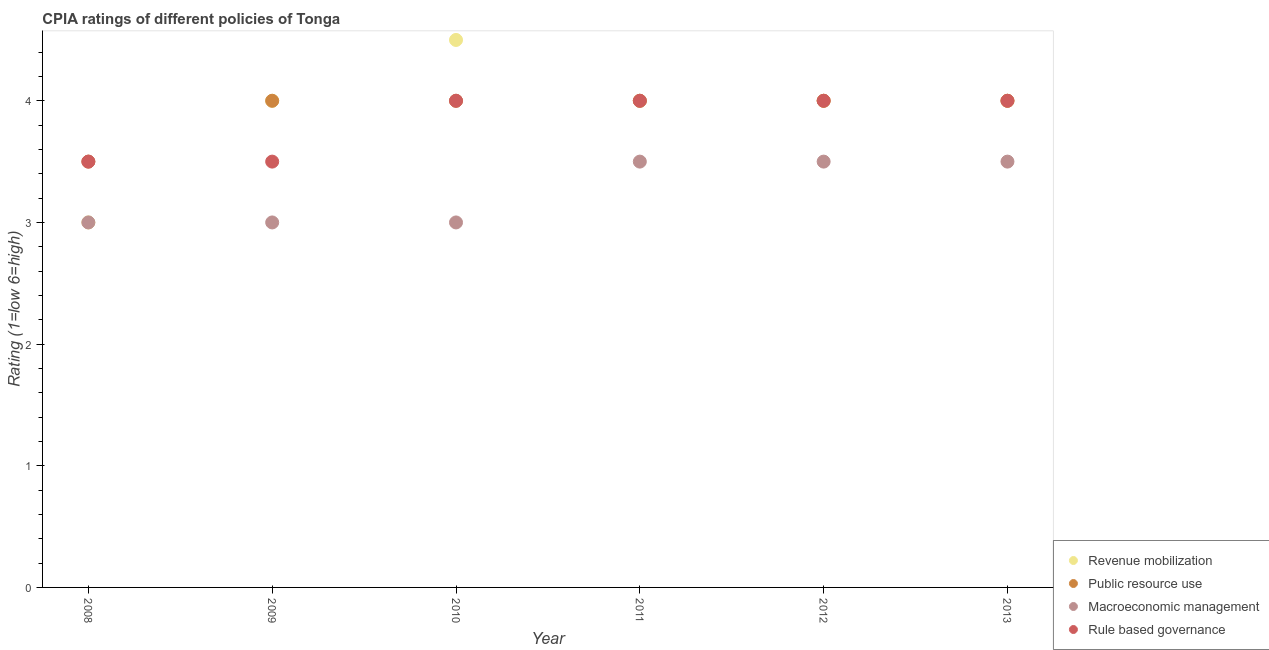How many different coloured dotlines are there?
Your answer should be very brief. 4. Is the number of dotlines equal to the number of legend labels?
Offer a terse response. Yes. Across all years, what is the maximum cpia rating of macroeconomic management?
Keep it short and to the point. 3.5. Across all years, what is the minimum cpia rating of macroeconomic management?
Keep it short and to the point. 3. In which year was the cpia rating of rule based governance maximum?
Provide a short and direct response. 2010. In which year was the cpia rating of public resource use minimum?
Your answer should be very brief. 2008. What is the total cpia rating of revenue mobilization in the graph?
Make the answer very short. 23.5. What is the difference between the cpia rating of public resource use in 2010 and the cpia rating of revenue mobilization in 2009?
Give a very brief answer. 0. What is the ratio of the cpia rating of macroeconomic management in 2008 to that in 2013?
Provide a short and direct response. 0.86. Is the cpia rating of public resource use in 2009 less than that in 2012?
Make the answer very short. No. Is the difference between the cpia rating of macroeconomic management in 2008 and 2010 greater than the difference between the cpia rating of rule based governance in 2008 and 2010?
Your answer should be compact. Yes. What is the difference between the highest and the lowest cpia rating of revenue mobilization?
Your response must be concise. 1.5. In how many years, is the cpia rating of macroeconomic management greater than the average cpia rating of macroeconomic management taken over all years?
Offer a very short reply. 3. Is the sum of the cpia rating of public resource use in 2009 and 2010 greater than the maximum cpia rating of macroeconomic management across all years?
Your answer should be compact. Yes. Is it the case that in every year, the sum of the cpia rating of revenue mobilization and cpia rating of public resource use is greater than the sum of cpia rating of rule based governance and cpia rating of macroeconomic management?
Provide a short and direct response. No. How many years are there in the graph?
Ensure brevity in your answer.  6. What is the difference between two consecutive major ticks on the Y-axis?
Make the answer very short. 1. Does the graph contain any zero values?
Your response must be concise. No. Does the graph contain grids?
Offer a very short reply. No. Where does the legend appear in the graph?
Make the answer very short. Bottom right. What is the title of the graph?
Your answer should be very brief. CPIA ratings of different policies of Tonga. Does "UNAIDS" appear as one of the legend labels in the graph?
Offer a terse response. No. What is the label or title of the X-axis?
Ensure brevity in your answer.  Year. What is the label or title of the Y-axis?
Your answer should be very brief. Rating (1=low 6=high). What is the Rating (1=low 6=high) of Public resource use in 2008?
Keep it short and to the point. 3.5. What is the Rating (1=low 6=high) in Revenue mobilization in 2009?
Make the answer very short. 4. What is the Rating (1=low 6=high) of Macroeconomic management in 2009?
Keep it short and to the point. 3. What is the Rating (1=low 6=high) in Revenue mobilization in 2010?
Your response must be concise. 4.5. What is the Rating (1=low 6=high) in Public resource use in 2010?
Offer a terse response. 4. What is the Rating (1=low 6=high) in Rule based governance in 2011?
Your answer should be compact. 4. What is the Rating (1=low 6=high) in Public resource use in 2012?
Ensure brevity in your answer.  4. What is the Rating (1=low 6=high) in Macroeconomic management in 2013?
Your response must be concise. 3.5. What is the Rating (1=low 6=high) of Rule based governance in 2013?
Offer a terse response. 4. Across all years, what is the maximum Rating (1=low 6=high) in Macroeconomic management?
Ensure brevity in your answer.  3.5. Across all years, what is the minimum Rating (1=low 6=high) in Public resource use?
Your answer should be very brief. 3.5. What is the total Rating (1=low 6=high) of Revenue mobilization in the graph?
Offer a terse response. 23.5. What is the total Rating (1=low 6=high) of Public resource use in the graph?
Your answer should be very brief. 23.5. What is the total Rating (1=low 6=high) in Rule based governance in the graph?
Provide a short and direct response. 23. What is the difference between the Rating (1=low 6=high) of Public resource use in 2008 and that in 2009?
Ensure brevity in your answer.  -0.5. What is the difference between the Rating (1=low 6=high) of Revenue mobilization in 2008 and that in 2010?
Offer a terse response. -1.5. What is the difference between the Rating (1=low 6=high) of Macroeconomic management in 2008 and that in 2010?
Provide a succinct answer. 0. What is the difference between the Rating (1=low 6=high) in Rule based governance in 2008 and that in 2010?
Your answer should be compact. -0.5. What is the difference between the Rating (1=low 6=high) in Revenue mobilization in 2008 and that in 2011?
Offer a terse response. -1. What is the difference between the Rating (1=low 6=high) of Public resource use in 2008 and that in 2011?
Provide a succinct answer. -0.5. What is the difference between the Rating (1=low 6=high) of Rule based governance in 2008 and that in 2011?
Provide a succinct answer. -0.5. What is the difference between the Rating (1=low 6=high) of Revenue mobilization in 2008 and that in 2012?
Make the answer very short. -1. What is the difference between the Rating (1=low 6=high) in Public resource use in 2008 and that in 2012?
Your answer should be compact. -0.5. What is the difference between the Rating (1=low 6=high) in Macroeconomic management in 2008 and that in 2012?
Your answer should be compact. -0.5. What is the difference between the Rating (1=low 6=high) of Revenue mobilization in 2008 and that in 2013?
Keep it short and to the point. -1. What is the difference between the Rating (1=low 6=high) of Public resource use in 2008 and that in 2013?
Provide a short and direct response. -0.5. What is the difference between the Rating (1=low 6=high) of Macroeconomic management in 2008 and that in 2013?
Make the answer very short. -0.5. What is the difference between the Rating (1=low 6=high) of Rule based governance in 2008 and that in 2013?
Give a very brief answer. -0.5. What is the difference between the Rating (1=low 6=high) of Revenue mobilization in 2009 and that in 2010?
Offer a terse response. -0.5. What is the difference between the Rating (1=low 6=high) in Macroeconomic management in 2009 and that in 2010?
Provide a short and direct response. 0. What is the difference between the Rating (1=low 6=high) in Revenue mobilization in 2009 and that in 2011?
Your response must be concise. 0. What is the difference between the Rating (1=low 6=high) in Public resource use in 2009 and that in 2011?
Provide a succinct answer. 0. What is the difference between the Rating (1=low 6=high) in Macroeconomic management in 2009 and that in 2011?
Your response must be concise. -0.5. What is the difference between the Rating (1=low 6=high) in Public resource use in 2009 and that in 2012?
Provide a short and direct response. 0. What is the difference between the Rating (1=low 6=high) of Macroeconomic management in 2009 and that in 2012?
Make the answer very short. -0.5. What is the difference between the Rating (1=low 6=high) in Revenue mobilization in 2009 and that in 2013?
Make the answer very short. 0. What is the difference between the Rating (1=low 6=high) in Rule based governance in 2009 and that in 2013?
Offer a very short reply. -0.5. What is the difference between the Rating (1=low 6=high) in Public resource use in 2010 and that in 2011?
Give a very brief answer. 0. What is the difference between the Rating (1=low 6=high) of Rule based governance in 2010 and that in 2011?
Your answer should be very brief. 0. What is the difference between the Rating (1=low 6=high) in Revenue mobilization in 2010 and that in 2012?
Keep it short and to the point. 0.5. What is the difference between the Rating (1=low 6=high) in Public resource use in 2010 and that in 2012?
Give a very brief answer. 0. What is the difference between the Rating (1=low 6=high) of Revenue mobilization in 2010 and that in 2013?
Provide a succinct answer. 0.5. What is the difference between the Rating (1=low 6=high) in Rule based governance in 2011 and that in 2012?
Provide a succinct answer. 0. What is the difference between the Rating (1=low 6=high) of Rule based governance in 2011 and that in 2013?
Your answer should be compact. 0. What is the difference between the Rating (1=low 6=high) in Macroeconomic management in 2012 and that in 2013?
Keep it short and to the point. 0. What is the difference between the Rating (1=low 6=high) of Rule based governance in 2012 and that in 2013?
Provide a succinct answer. 0. What is the difference between the Rating (1=low 6=high) in Revenue mobilization in 2008 and the Rating (1=low 6=high) in Macroeconomic management in 2009?
Your answer should be compact. 0. What is the difference between the Rating (1=low 6=high) in Macroeconomic management in 2008 and the Rating (1=low 6=high) in Rule based governance in 2009?
Your answer should be very brief. -0.5. What is the difference between the Rating (1=low 6=high) of Revenue mobilization in 2008 and the Rating (1=low 6=high) of Macroeconomic management in 2010?
Give a very brief answer. 0. What is the difference between the Rating (1=low 6=high) in Public resource use in 2008 and the Rating (1=low 6=high) in Macroeconomic management in 2010?
Provide a succinct answer. 0.5. What is the difference between the Rating (1=low 6=high) in Public resource use in 2008 and the Rating (1=low 6=high) in Rule based governance in 2010?
Offer a very short reply. -0.5. What is the difference between the Rating (1=low 6=high) in Revenue mobilization in 2008 and the Rating (1=low 6=high) in Public resource use in 2011?
Ensure brevity in your answer.  -1. What is the difference between the Rating (1=low 6=high) in Revenue mobilization in 2008 and the Rating (1=low 6=high) in Macroeconomic management in 2011?
Your answer should be compact. -0.5. What is the difference between the Rating (1=low 6=high) of Public resource use in 2008 and the Rating (1=low 6=high) of Macroeconomic management in 2011?
Your answer should be very brief. 0. What is the difference between the Rating (1=low 6=high) of Public resource use in 2008 and the Rating (1=low 6=high) of Rule based governance in 2011?
Your answer should be very brief. -0.5. What is the difference between the Rating (1=low 6=high) in Revenue mobilization in 2008 and the Rating (1=low 6=high) in Macroeconomic management in 2012?
Keep it short and to the point. -0.5. What is the difference between the Rating (1=low 6=high) of Public resource use in 2008 and the Rating (1=low 6=high) of Rule based governance in 2012?
Your answer should be very brief. -0.5. What is the difference between the Rating (1=low 6=high) of Revenue mobilization in 2008 and the Rating (1=low 6=high) of Rule based governance in 2013?
Offer a terse response. -1. What is the difference between the Rating (1=low 6=high) in Public resource use in 2008 and the Rating (1=low 6=high) in Macroeconomic management in 2013?
Your answer should be very brief. 0. What is the difference between the Rating (1=low 6=high) of Macroeconomic management in 2008 and the Rating (1=low 6=high) of Rule based governance in 2013?
Ensure brevity in your answer.  -1. What is the difference between the Rating (1=low 6=high) of Revenue mobilization in 2009 and the Rating (1=low 6=high) of Public resource use in 2010?
Provide a succinct answer. 0. What is the difference between the Rating (1=low 6=high) of Revenue mobilization in 2009 and the Rating (1=low 6=high) of Macroeconomic management in 2010?
Offer a terse response. 1. What is the difference between the Rating (1=low 6=high) of Public resource use in 2009 and the Rating (1=low 6=high) of Rule based governance in 2010?
Ensure brevity in your answer.  0. What is the difference between the Rating (1=low 6=high) in Macroeconomic management in 2009 and the Rating (1=low 6=high) in Rule based governance in 2010?
Your answer should be very brief. -1. What is the difference between the Rating (1=low 6=high) in Public resource use in 2009 and the Rating (1=low 6=high) in Macroeconomic management in 2011?
Offer a terse response. 0.5. What is the difference between the Rating (1=low 6=high) of Revenue mobilization in 2009 and the Rating (1=low 6=high) of Public resource use in 2012?
Your answer should be compact. 0. What is the difference between the Rating (1=low 6=high) of Revenue mobilization in 2009 and the Rating (1=low 6=high) of Macroeconomic management in 2012?
Your response must be concise. 0.5. What is the difference between the Rating (1=low 6=high) in Revenue mobilization in 2009 and the Rating (1=low 6=high) in Rule based governance in 2012?
Ensure brevity in your answer.  0. What is the difference between the Rating (1=low 6=high) in Macroeconomic management in 2009 and the Rating (1=low 6=high) in Rule based governance in 2012?
Ensure brevity in your answer.  -1. What is the difference between the Rating (1=low 6=high) in Revenue mobilization in 2009 and the Rating (1=low 6=high) in Public resource use in 2013?
Provide a short and direct response. 0. What is the difference between the Rating (1=low 6=high) in Revenue mobilization in 2009 and the Rating (1=low 6=high) in Rule based governance in 2013?
Provide a short and direct response. 0. What is the difference between the Rating (1=low 6=high) of Public resource use in 2009 and the Rating (1=low 6=high) of Rule based governance in 2013?
Provide a short and direct response. 0. What is the difference between the Rating (1=low 6=high) in Macroeconomic management in 2009 and the Rating (1=low 6=high) in Rule based governance in 2013?
Provide a succinct answer. -1. What is the difference between the Rating (1=low 6=high) of Public resource use in 2010 and the Rating (1=low 6=high) of Macroeconomic management in 2011?
Make the answer very short. 0.5. What is the difference between the Rating (1=low 6=high) in Macroeconomic management in 2010 and the Rating (1=low 6=high) in Rule based governance in 2011?
Your answer should be compact. -1. What is the difference between the Rating (1=low 6=high) of Revenue mobilization in 2010 and the Rating (1=low 6=high) of Public resource use in 2012?
Your response must be concise. 0.5. What is the difference between the Rating (1=low 6=high) of Public resource use in 2010 and the Rating (1=low 6=high) of Macroeconomic management in 2012?
Your answer should be very brief. 0.5. What is the difference between the Rating (1=low 6=high) in Public resource use in 2010 and the Rating (1=low 6=high) in Rule based governance in 2012?
Keep it short and to the point. 0. What is the difference between the Rating (1=low 6=high) in Macroeconomic management in 2010 and the Rating (1=low 6=high) in Rule based governance in 2012?
Provide a succinct answer. -1. What is the difference between the Rating (1=low 6=high) of Revenue mobilization in 2010 and the Rating (1=low 6=high) of Public resource use in 2013?
Ensure brevity in your answer.  0.5. What is the difference between the Rating (1=low 6=high) in Revenue mobilization in 2010 and the Rating (1=low 6=high) in Macroeconomic management in 2013?
Offer a terse response. 1. What is the difference between the Rating (1=low 6=high) in Revenue mobilization in 2010 and the Rating (1=low 6=high) in Rule based governance in 2013?
Your response must be concise. 0.5. What is the difference between the Rating (1=low 6=high) in Public resource use in 2010 and the Rating (1=low 6=high) in Macroeconomic management in 2013?
Make the answer very short. 0.5. What is the difference between the Rating (1=low 6=high) in Macroeconomic management in 2010 and the Rating (1=low 6=high) in Rule based governance in 2013?
Make the answer very short. -1. What is the difference between the Rating (1=low 6=high) of Revenue mobilization in 2011 and the Rating (1=low 6=high) of Macroeconomic management in 2012?
Make the answer very short. 0.5. What is the difference between the Rating (1=low 6=high) in Public resource use in 2011 and the Rating (1=low 6=high) in Macroeconomic management in 2012?
Offer a very short reply. 0.5. What is the difference between the Rating (1=low 6=high) of Public resource use in 2011 and the Rating (1=low 6=high) of Macroeconomic management in 2013?
Your answer should be very brief. 0.5. What is the difference between the Rating (1=low 6=high) of Public resource use in 2011 and the Rating (1=low 6=high) of Rule based governance in 2013?
Give a very brief answer. 0. What is the difference between the Rating (1=low 6=high) in Revenue mobilization in 2012 and the Rating (1=low 6=high) in Macroeconomic management in 2013?
Keep it short and to the point. 0.5. What is the difference between the Rating (1=low 6=high) in Public resource use in 2012 and the Rating (1=low 6=high) in Macroeconomic management in 2013?
Keep it short and to the point. 0.5. What is the difference between the Rating (1=low 6=high) in Macroeconomic management in 2012 and the Rating (1=low 6=high) in Rule based governance in 2013?
Offer a very short reply. -0.5. What is the average Rating (1=low 6=high) in Revenue mobilization per year?
Provide a short and direct response. 3.92. What is the average Rating (1=low 6=high) in Public resource use per year?
Your answer should be compact. 3.92. What is the average Rating (1=low 6=high) in Macroeconomic management per year?
Your answer should be compact. 3.25. What is the average Rating (1=low 6=high) in Rule based governance per year?
Provide a short and direct response. 3.83. In the year 2008, what is the difference between the Rating (1=low 6=high) in Revenue mobilization and Rating (1=low 6=high) in Public resource use?
Keep it short and to the point. -0.5. In the year 2008, what is the difference between the Rating (1=low 6=high) of Revenue mobilization and Rating (1=low 6=high) of Macroeconomic management?
Provide a succinct answer. 0. In the year 2008, what is the difference between the Rating (1=low 6=high) in Revenue mobilization and Rating (1=low 6=high) in Rule based governance?
Provide a short and direct response. -0.5. In the year 2008, what is the difference between the Rating (1=low 6=high) in Public resource use and Rating (1=low 6=high) in Macroeconomic management?
Give a very brief answer. 0.5. In the year 2008, what is the difference between the Rating (1=low 6=high) in Macroeconomic management and Rating (1=low 6=high) in Rule based governance?
Ensure brevity in your answer.  -0.5. In the year 2009, what is the difference between the Rating (1=low 6=high) in Revenue mobilization and Rating (1=low 6=high) in Public resource use?
Your response must be concise. 0. In the year 2009, what is the difference between the Rating (1=low 6=high) of Revenue mobilization and Rating (1=low 6=high) of Macroeconomic management?
Provide a short and direct response. 1. In the year 2009, what is the difference between the Rating (1=low 6=high) of Public resource use and Rating (1=low 6=high) of Macroeconomic management?
Provide a succinct answer. 1. In the year 2010, what is the difference between the Rating (1=low 6=high) in Revenue mobilization and Rating (1=low 6=high) in Rule based governance?
Provide a short and direct response. 0.5. In the year 2010, what is the difference between the Rating (1=low 6=high) of Public resource use and Rating (1=low 6=high) of Rule based governance?
Offer a very short reply. 0. In the year 2010, what is the difference between the Rating (1=low 6=high) of Macroeconomic management and Rating (1=low 6=high) of Rule based governance?
Your answer should be very brief. -1. In the year 2011, what is the difference between the Rating (1=low 6=high) of Revenue mobilization and Rating (1=low 6=high) of Macroeconomic management?
Provide a short and direct response. 0.5. In the year 2012, what is the difference between the Rating (1=low 6=high) in Revenue mobilization and Rating (1=low 6=high) in Macroeconomic management?
Your answer should be very brief. 0.5. In the year 2012, what is the difference between the Rating (1=low 6=high) of Public resource use and Rating (1=low 6=high) of Macroeconomic management?
Make the answer very short. 0.5. In the year 2013, what is the difference between the Rating (1=low 6=high) in Revenue mobilization and Rating (1=low 6=high) in Public resource use?
Ensure brevity in your answer.  0. In the year 2013, what is the difference between the Rating (1=low 6=high) of Revenue mobilization and Rating (1=low 6=high) of Macroeconomic management?
Give a very brief answer. 0.5. In the year 2013, what is the difference between the Rating (1=low 6=high) in Revenue mobilization and Rating (1=low 6=high) in Rule based governance?
Provide a short and direct response. 0. In the year 2013, what is the difference between the Rating (1=low 6=high) in Public resource use and Rating (1=low 6=high) in Macroeconomic management?
Your response must be concise. 0.5. What is the ratio of the Rating (1=low 6=high) of Macroeconomic management in 2008 to that in 2009?
Your answer should be very brief. 1. What is the ratio of the Rating (1=low 6=high) in Rule based governance in 2008 to that in 2009?
Ensure brevity in your answer.  1. What is the ratio of the Rating (1=low 6=high) in Macroeconomic management in 2008 to that in 2010?
Make the answer very short. 1. What is the ratio of the Rating (1=low 6=high) in Rule based governance in 2008 to that in 2010?
Offer a very short reply. 0.88. What is the ratio of the Rating (1=low 6=high) of Revenue mobilization in 2008 to that in 2011?
Your response must be concise. 0.75. What is the ratio of the Rating (1=low 6=high) of Macroeconomic management in 2008 to that in 2011?
Your answer should be very brief. 0.86. What is the ratio of the Rating (1=low 6=high) of Rule based governance in 2008 to that in 2011?
Provide a succinct answer. 0.88. What is the ratio of the Rating (1=low 6=high) in Revenue mobilization in 2008 to that in 2012?
Provide a succinct answer. 0.75. What is the ratio of the Rating (1=low 6=high) of Public resource use in 2008 to that in 2013?
Offer a terse response. 0.88. What is the ratio of the Rating (1=low 6=high) in Revenue mobilization in 2009 to that in 2010?
Provide a short and direct response. 0.89. What is the ratio of the Rating (1=low 6=high) of Public resource use in 2009 to that in 2010?
Offer a very short reply. 1. What is the ratio of the Rating (1=low 6=high) in Macroeconomic management in 2009 to that in 2010?
Offer a terse response. 1. What is the ratio of the Rating (1=low 6=high) of Rule based governance in 2009 to that in 2010?
Offer a terse response. 0.88. What is the ratio of the Rating (1=low 6=high) in Public resource use in 2009 to that in 2011?
Make the answer very short. 1. What is the ratio of the Rating (1=low 6=high) of Public resource use in 2009 to that in 2012?
Keep it short and to the point. 1. What is the ratio of the Rating (1=low 6=high) in Revenue mobilization in 2009 to that in 2013?
Your answer should be very brief. 1. What is the ratio of the Rating (1=low 6=high) in Revenue mobilization in 2010 to that in 2011?
Your response must be concise. 1.12. What is the ratio of the Rating (1=low 6=high) in Macroeconomic management in 2010 to that in 2011?
Your response must be concise. 0.86. What is the ratio of the Rating (1=low 6=high) of Revenue mobilization in 2010 to that in 2012?
Keep it short and to the point. 1.12. What is the ratio of the Rating (1=low 6=high) in Public resource use in 2010 to that in 2012?
Ensure brevity in your answer.  1. What is the ratio of the Rating (1=low 6=high) of Rule based governance in 2010 to that in 2012?
Keep it short and to the point. 1. What is the ratio of the Rating (1=low 6=high) of Revenue mobilization in 2011 to that in 2013?
Provide a succinct answer. 1. What is the ratio of the Rating (1=low 6=high) of Rule based governance in 2011 to that in 2013?
Provide a succinct answer. 1. What is the ratio of the Rating (1=low 6=high) of Public resource use in 2012 to that in 2013?
Give a very brief answer. 1. What is the ratio of the Rating (1=low 6=high) of Macroeconomic management in 2012 to that in 2013?
Provide a short and direct response. 1. What is the difference between the highest and the second highest Rating (1=low 6=high) in Macroeconomic management?
Ensure brevity in your answer.  0. What is the difference between the highest and the second highest Rating (1=low 6=high) of Rule based governance?
Give a very brief answer. 0. What is the difference between the highest and the lowest Rating (1=low 6=high) in Public resource use?
Keep it short and to the point. 0.5. What is the difference between the highest and the lowest Rating (1=low 6=high) in Rule based governance?
Give a very brief answer. 0.5. 